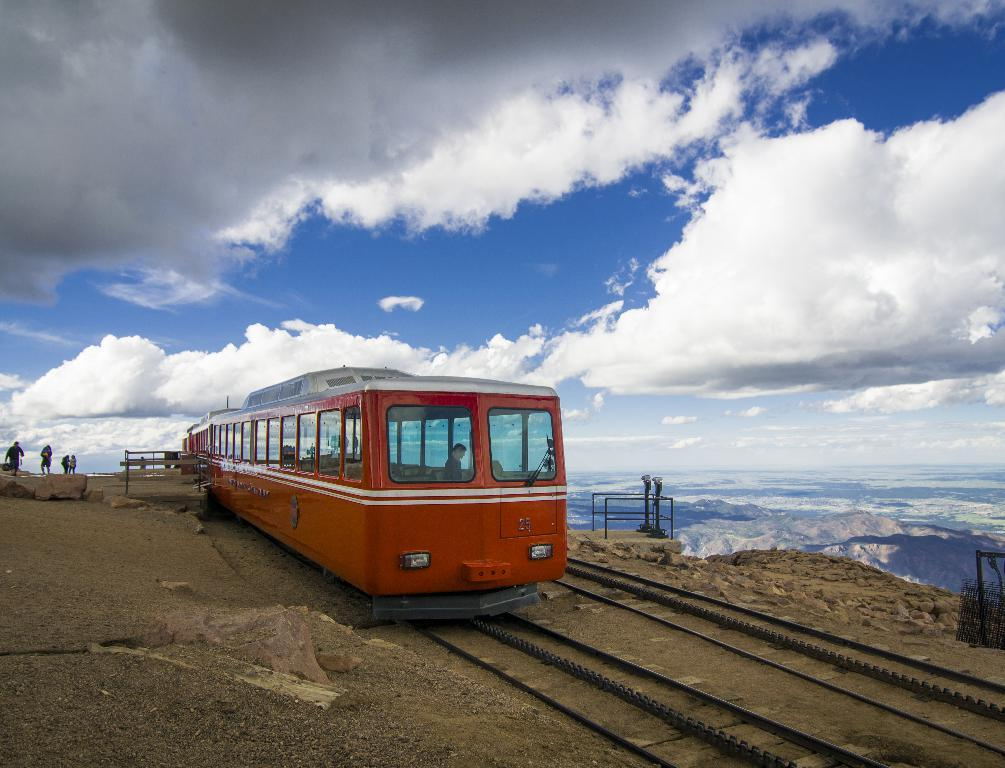What is the main subject in the center of the image? There is a train in the center of the image. What is the train's location in relation to the railway track? The train is on a railway track. What can be seen on the left side of the image? There are persons and rocks on the left side of the image. What is visible in the background of the image? There are hills and the sky in the background of the image. What can be observed in the sky? There are clouds in the sky. What hobbies do the rocks on the left side of the image have? Rocks do not have hobbies, as they are inanimate objects. What type of bread is being used as a pillow for the achiever in the image? There is no person or achiever present in the image, and therefore no bread or pillow can be observed. 